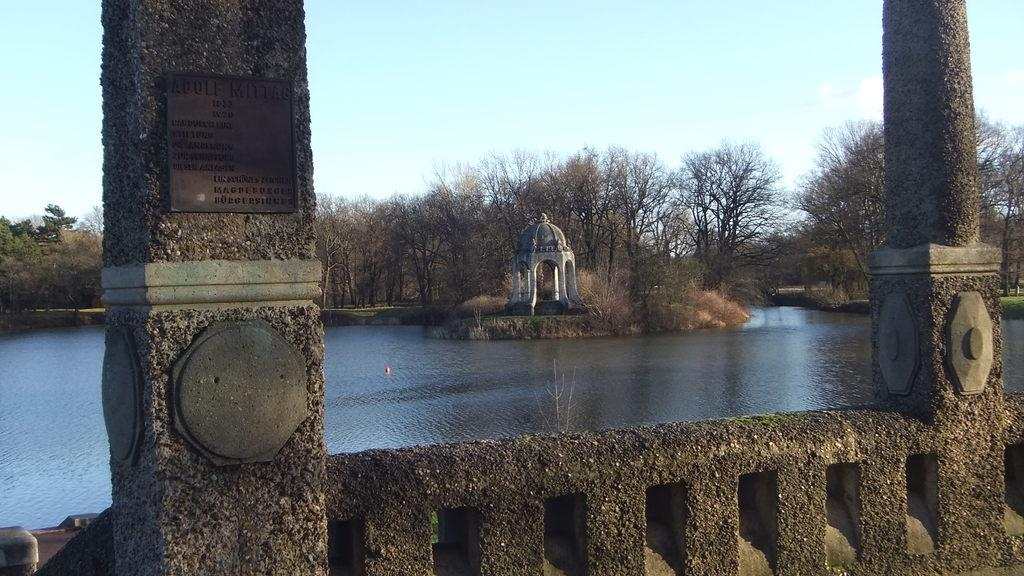What structures are located on the sides of the image? There are two pillars on the right and left side of the image. What is in the center of the image? There is water in the center of the image. What can be seen in the background of the image? There are trees in the background area of the image. How is the glue being used in the image? There is no glue present in the image. What type of steam can be seen rising from the water in the image? There is no steam visible in the image; it is water without any steam. 